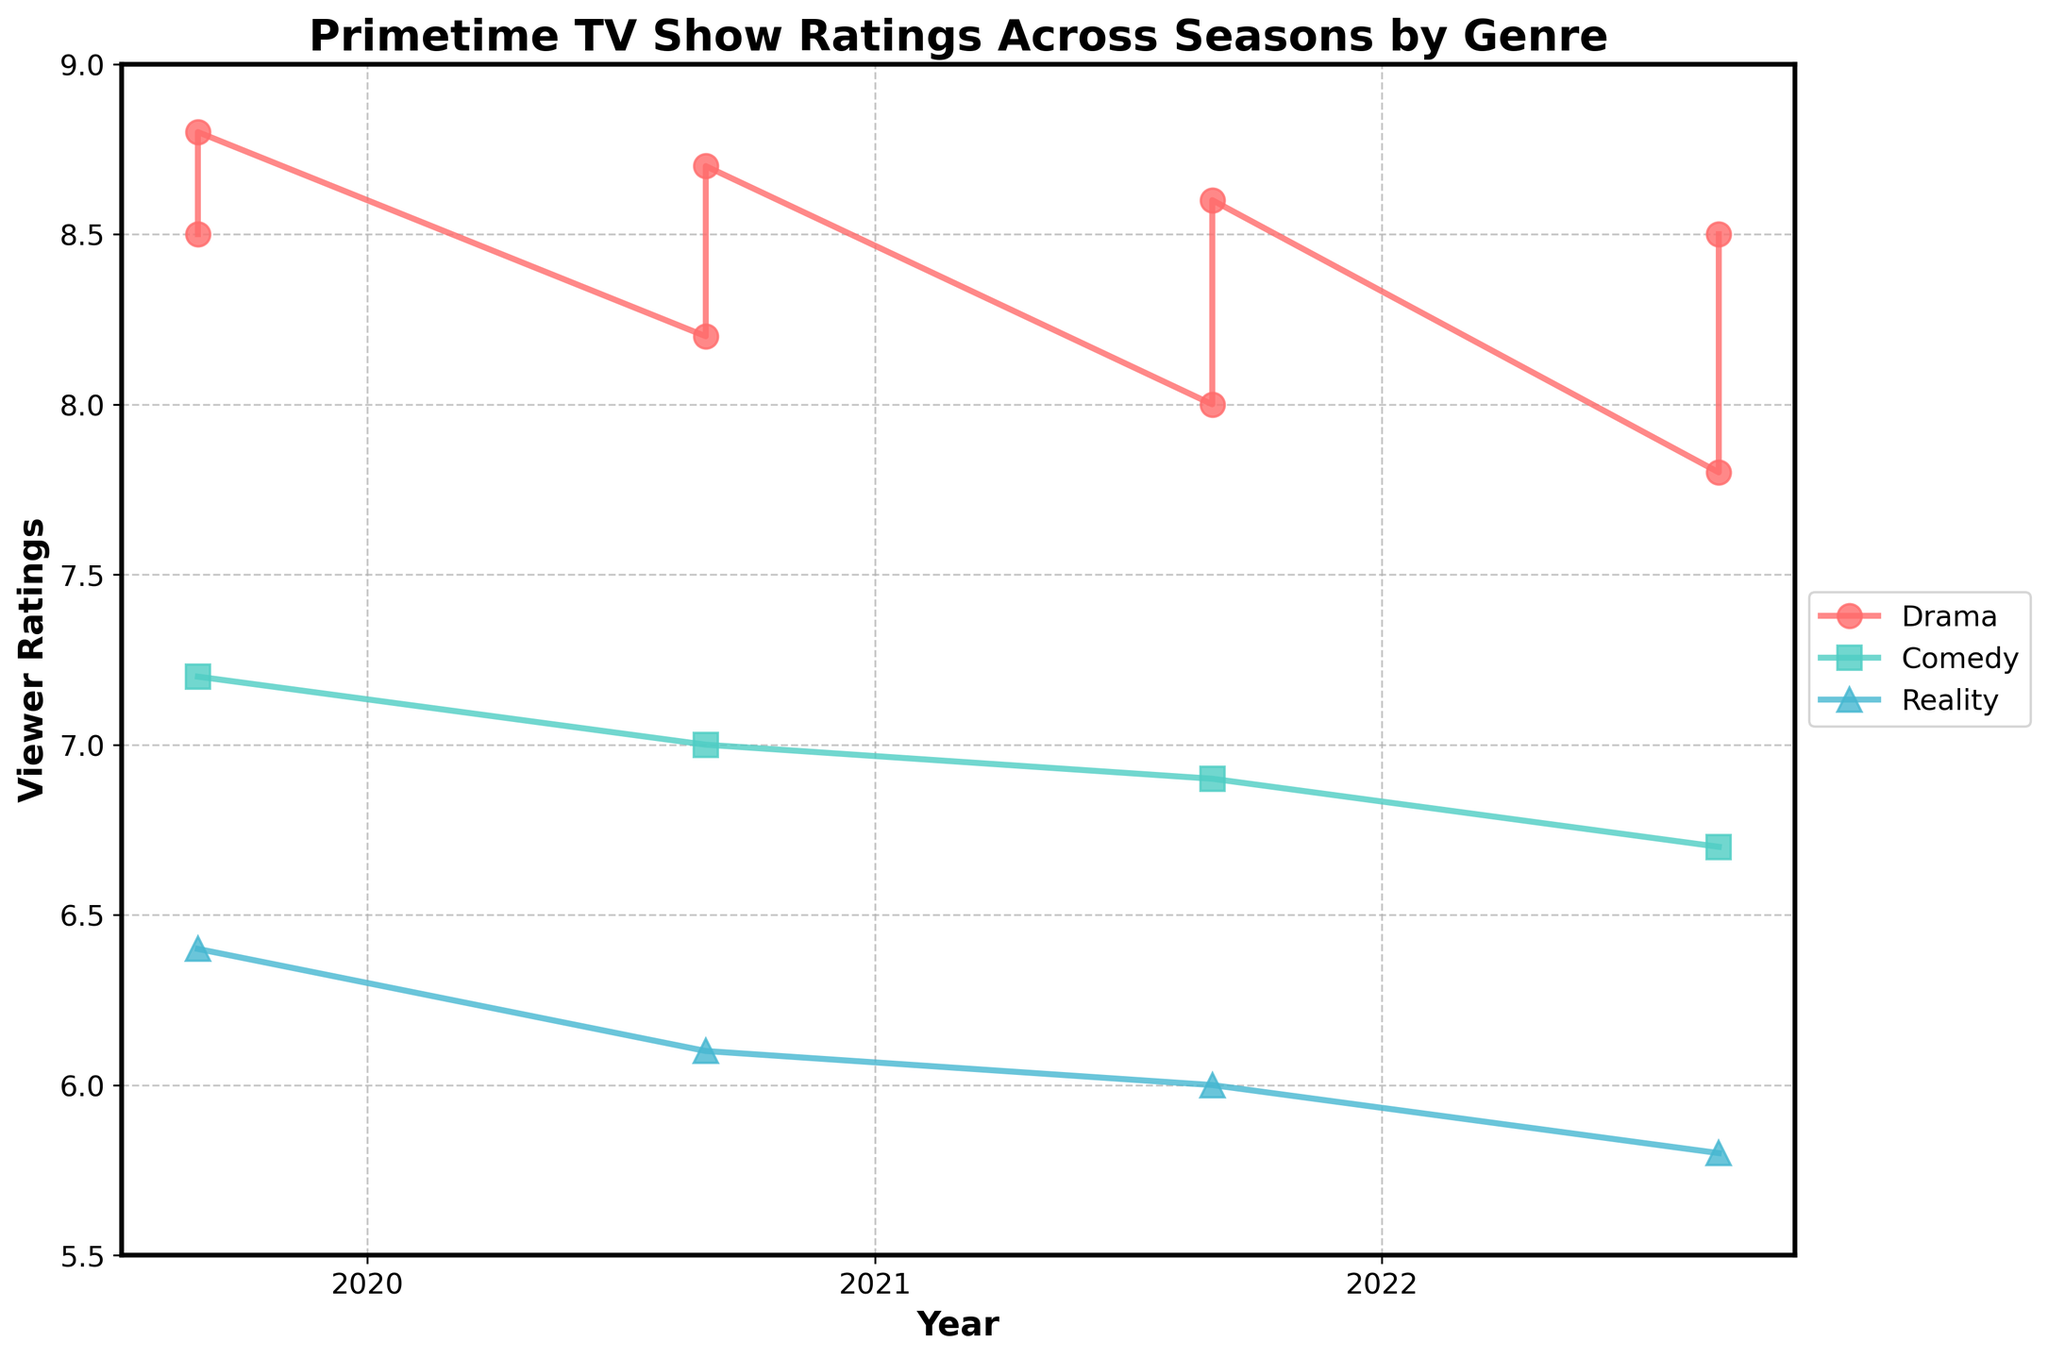What genres are presented in the plot? The legend indicates three genres: Drama, Comedy, and Reality.
Answer: Drama, Comedy, Reality What is the highest viewer rating recorded on the plot, and which show does it belong to? The highest value on the y-axis, labeled as Viewer Ratings, is 8.8. This rating belongs to "Stranger Things" in Drama genre in 2019.
Answer: Stranger Things, Drama, 8.8 How do the viewer ratings for "The Big Bang Theory" change over the seasons? By analyzing the trend for the Comedy genre, the plot shows "The Big Bang Theory" ratings starting at 7.2 in 2019, then dropping to 7.0, 6.9, and 6.7 over the subsequent years.
Answer: 7.2, 7.0, 6.9, 6.7 Compare the trend of viewer ratings for "Game of Thrones" and "Survivor" from 2019 to 2022. The Drama genre (Game of Thrones) shows a declining trend from 8.5 to 7.8. The Reality genre (Survivor) also shows a declining trend from 6.4 to 5.8. Both shows have a downward trajectory.
Answer: Both shows decline What is the average viewer rating for the Drama genre across all the seasons? Add the Drama ratings (8.5, 8.8, 8.2, 8.7, 8.0, 8.6, 7.8, 8.5) and divide by the number of data points (8): (8.5+8.8+8.2+8.7+8.0+8.6+7.8+8.5)/8 = 8.39
Answer: 8.39 Which genre has shown the most stability (least variation) in viewer ratings across seasons? By comparing the trends of the three genres, the Comedy genre has the smallest variation in its ratings (ranging only from 7.2 to 6.7) compared to Drama and Reality.
Answer: Comedy In which year did "Stranger Things" have the highest viewer rating, and what was it? Reviewing the Drama genre, "Stranger Things" had the highest rating of 8.8 in 2019.
Answer: 2019, 8.8 Did any genre have a year where their viewer rating increased compared to the previous season? By examining the trajectories of each genre, none showed an increase in viewer ratings year over year. All genres either declined or remained stable.
Answer: No 